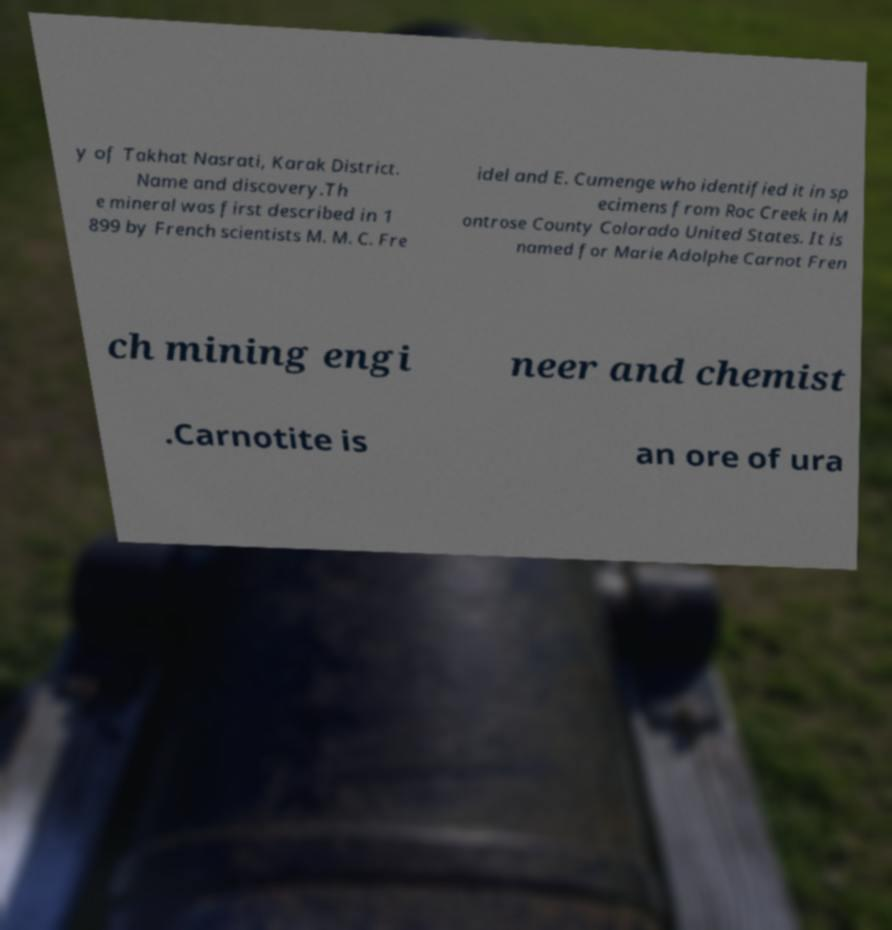There's text embedded in this image that I need extracted. Can you transcribe it verbatim? y of Takhat Nasrati, Karak District. Name and discovery.Th e mineral was first described in 1 899 by French scientists M. M. C. Fre idel and E. Cumenge who identified it in sp ecimens from Roc Creek in M ontrose County Colorado United States. It is named for Marie Adolphe Carnot Fren ch mining engi neer and chemist .Carnotite is an ore of ura 